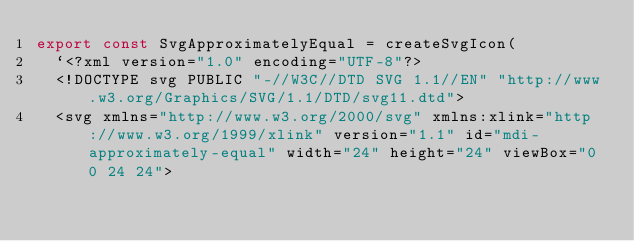Convert code to text. <code><loc_0><loc_0><loc_500><loc_500><_TypeScript_>export const SvgApproximatelyEqual = createSvgIcon(
  `<?xml version="1.0" encoding="UTF-8"?>
  <!DOCTYPE svg PUBLIC "-//W3C//DTD SVG 1.1//EN" "http://www.w3.org/Graphics/SVG/1.1/DTD/svg11.dtd">
  <svg xmlns="http://www.w3.org/2000/svg" xmlns:xlink="http://www.w3.org/1999/xlink" version="1.1" id="mdi-approximately-equal" width="24" height="24" viewBox="0 0 24 24"></code> 